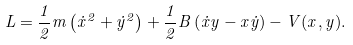Convert formula to latex. <formula><loc_0><loc_0><loc_500><loc_500>L = \frac { 1 } { 2 } m \left ( \dot { x } ^ { 2 } + \dot { y } ^ { 2 } \right ) + \frac { 1 } { 2 } B \left ( \dot { x } y - x \dot { y } \right ) - V ( x , y ) .</formula> 